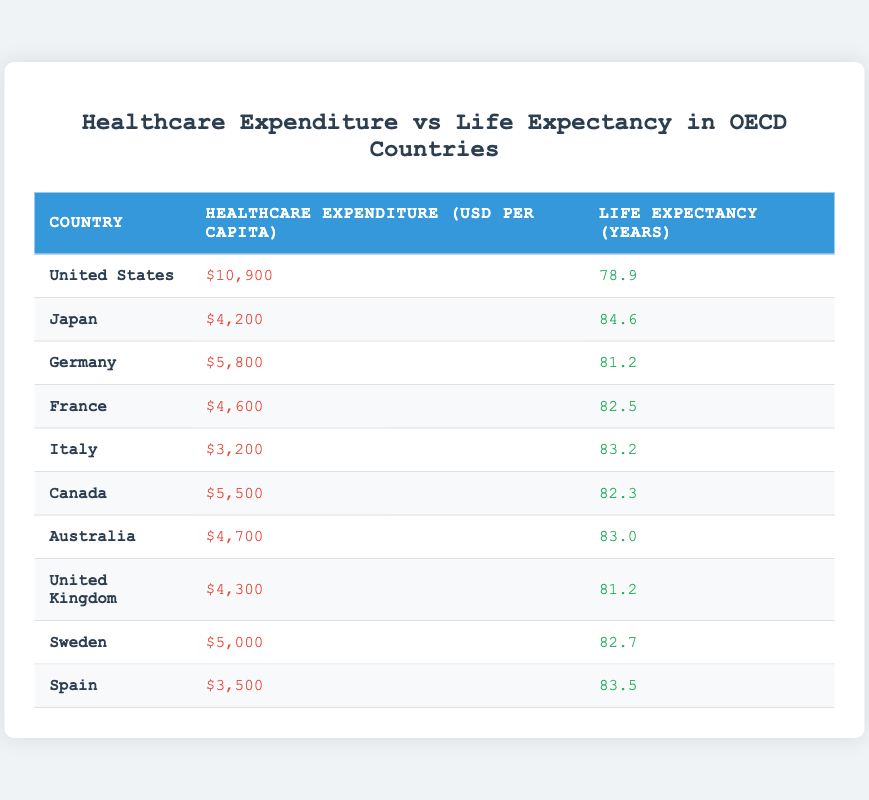What is the life expectancy in Japan? From the table, the life expectancy for Japan is directly listed as 84.6 years.
Answer: 84.6 Which country has the highest healthcare expenditure per capita? The table shows that the United States has the highest healthcare expenditure per capita at 10,900 USD.
Answer: United States What is the average life expectancy of the countries listed in the table? To find the average, we add up all the life expectancies: 78.9 + 84.6 + 81.2 + 82.5 + 83.2 + 82.3 + 83.0 + 81.2 + 82.7 + 83.5 = 828.0. There are 10 countries, so 828.0 / 10 = 82.8 years.
Answer: 82.8 Is there a country where the healthcare expenditure per capita is lower than 4,000 USD? By reviewing the expenditures, all listed countries have healthcare expenditures above 3,200 USD, therefore, no country has an expenditure lower than 4,000 USD.
Answer: No What is the difference in life expectancy between the United States and Japan? The life expectancy in the United States is 78.9 years, and in Japan, it is 84.6 years. The difference is 84.6 - 78.9 = 5.7 years.
Answer: 5.7 Which country has the second highest life expectancy, and what is it? Sorting the life expectancy values, Japan has the highest (84.6), and Italy has the second highest at 83.2 years.
Answer: Italy, 83.2 What is the sum of healthcare expenditures for Canada, France, and Australia? We add the expenditures: Canada (5,500) + France (4,600) + Australia (4,700) = 14,800 USD.
Answer: 14,800 Are there more countries with life expectancy above 82 years than below? The life expectancies above 82 years are from Japan, Italy, France, Canada, Australia, Spain, and Sweden (total of 7). The countries below 82 years are the United States, Germany, and the United Kingdom (total of 3). Since 7 is greater than 3, the answer is yes.
Answer: Yes 